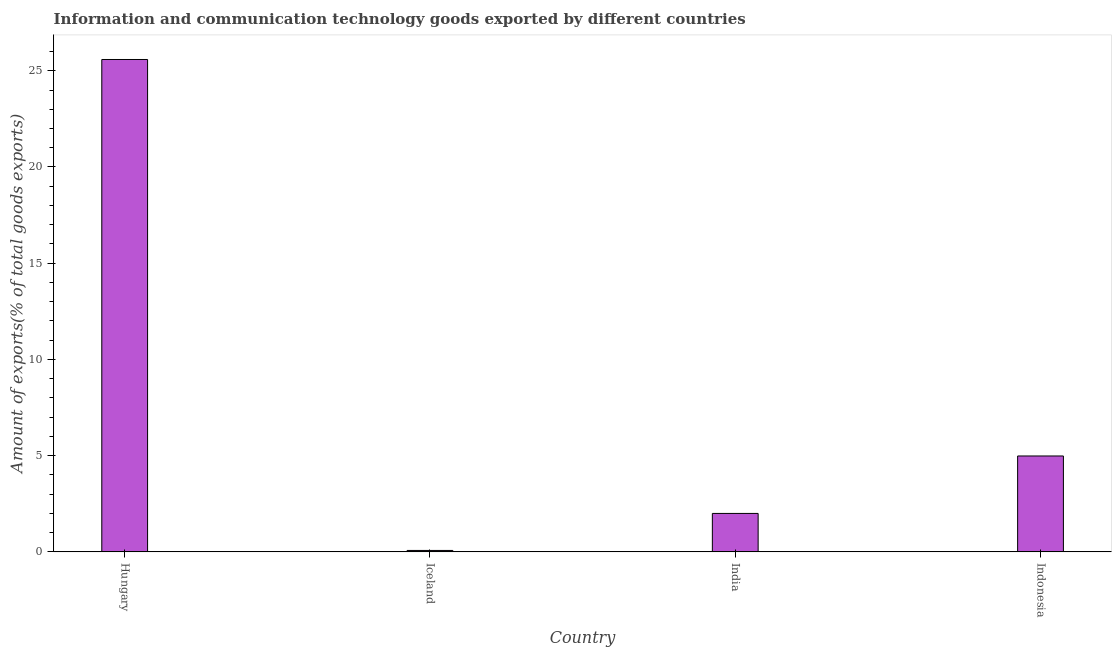Does the graph contain any zero values?
Ensure brevity in your answer.  No. Does the graph contain grids?
Offer a very short reply. No. What is the title of the graph?
Make the answer very short. Information and communication technology goods exported by different countries. What is the label or title of the X-axis?
Make the answer very short. Country. What is the label or title of the Y-axis?
Your answer should be very brief. Amount of exports(% of total goods exports). What is the amount of ict goods exports in India?
Your response must be concise. 2. Across all countries, what is the maximum amount of ict goods exports?
Offer a very short reply. 25.59. Across all countries, what is the minimum amount of ict goods exports?
Give a very brief answer. 0.07. In which country was the amount of ict goods exports maximum?
Keep it short and to the point. Hungary. What is the sum of the amount of ict goods exports?
Make the answer very short. 32.64. What is the difference between the amount of ict goods exports in Hungary and Iceland?
Offer a very short reply. 25.51. What is the average amount of ict goods exports per country?
Keep it short and to the point. 8.16. What is the median amount of ict goods exports?
Your answer should be very brief. 3.49. What is the ratio of the amount of ict goods exports in Iceland to that in India?
Offer a very short reply. 0.04. What is the difference between the highest and the second highest amount of ict goods exports?
Provide a succinct answer. 20.6. Is the sum of the amount of ict goods exports in Iceland and Indonesia greater than the maximum amount of ict goods exports across all countries?
Provide a short and direct response. No. What is the difference between the highest and the lowest amount of ict goods exports?
Keep it short and to the point. 25.51. In how many countries, is the amount of ict goods exports greater than the average amount of ict goods exports taken over all countries?
Ensure brevity in your answer.  1. Are the values on the major ticks of Y-axis written in scientific E-notation?
Provide a succinct answer. No. What is the Amount of exports(% of total goods exports) in Hungary?
Ensure brevity in your answer.  25.59. What is the Amount of exports(% of total goods exports) in Iceland?
Ensure brevity in your answer.  0.07. What is the Amount of exports(% of total goods exports) in India?
Provide a short and direct response. 2. What is the Amount of exports(% of total goods exports) in Indonesia?
Provide a succinct answer. 4.98. What is the difference between the Amount of exports(% of total goods exports) in Hungary and Iceland?
Your answer should be compact. 25.51. What is the difference between the Amount of exports(% of total goods exports) in Hungary and India?
Ensure brevity in your answer.  23.59. What is the difference between the Amount of exports(% of total goods exports) in Hungary and Indonesia?
Offer a terse response. 20.6. What is the difference between the Amount of exports(% of total goods exports) in Iceland and India?
Offer a terse response. -1.92. What is the difference between the Amount of exports(% of total goods exports) in Iceland and Indonesia?
Offer a very short reply. -4.91. What is the difference between the Amount of exports(% of total goods exports) in India and Indonesia?
Provide a short and direct response. -2.99. What is the ratio of the Amount of exports(% of total goods exports) in Hungary to that in Iceland?
Offer a very short reply. 344.4. What is the ratio of the Amount of exports(% of total goods exports) in Hungary to that in India?
Your answer should be very brief. 12.8. What is the ratio of the Amount of exports(% of total goods exports) in Hungary to that in Indonesia?
Your response must be concise. 5.13. What is the ratio of the Amount of exports(% of total goods exports) in Iceland to that in India?
Offer a terse response. 0.04. What is the ratio of the Amount of exports(% of total goods exports) in Iceland to that in Indonesia?
Keep it short and to the point. 0.01. What is the ratio of the Amount of exports(% of total goods exports) in India to that in Indonesia?
Your response must be concise. 0.4. 